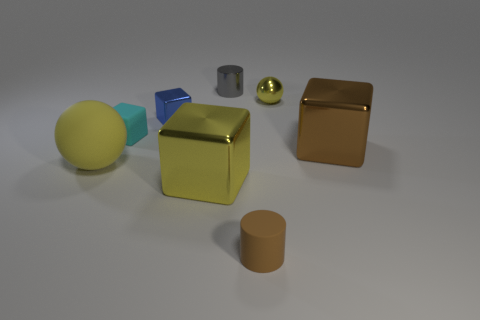Subtract all small shiny cubes. How many cubes are left? 3 Add 1 tiny metallic spheres. How many objects exist? 9 Subtract 1 balls. How many balls are left? 1 Subtract all yellow blocks. How many blocks are left? 3 Subtract all balls. How many objects are left? 6 Add 8 cyan things. How many cyan things are left? 9 Add 5 large cyan cubes. How many large cyan cubes exist? 5 Subtract 0 blue cylinders. How many objects are left? 8 Subtract all yellow cylinders. Subtract all yellow balls. How many cylinders are left? 2 Subtract all green rubber objects. Subtract all small cyan rubber cubes. How many objects are left? 7 